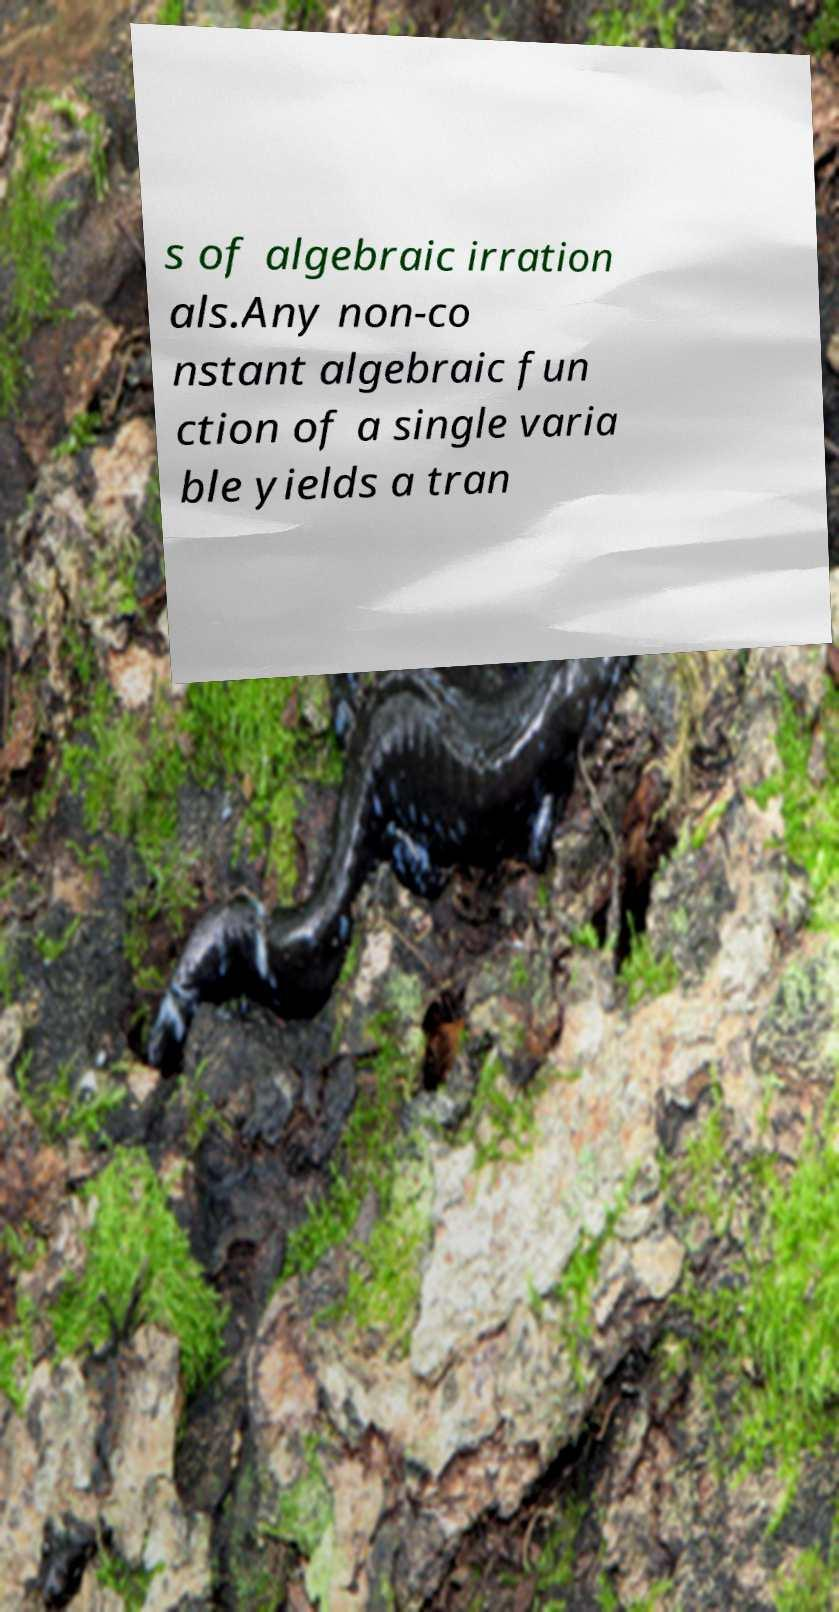Can you accurately transcribe the text from the provided image for me? s of algebraic irration als.Any non-co nstant algebraic fun ction of a single varia ble yields a tran 